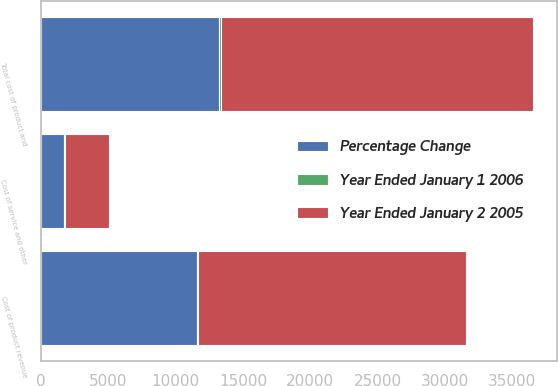<chart> <loc_0><loc_0><loc_500><loc_500><stacked_bar_chart><ecel><fcel>Cost of product revenue<fcel>Cost of service and other<fcel>Total cost of product and<nl><fcel>Year Ended January 2 2005<fcel>19920<fcel>3261<fcel>23181<nl><fcel>Percentage Change<fcel>11572<fcel>1687<fcel>13259<nl><fcel>Year Ended January 1 2006<fcel>72<fcel>93<fcel>75<nl></chart> 